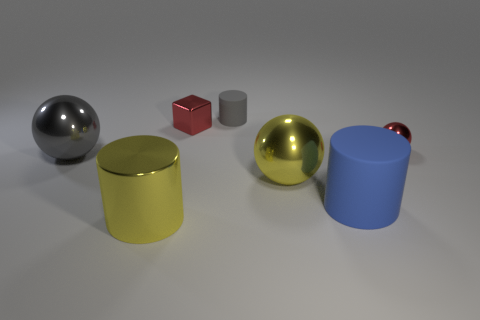Does the metal cylinder have the same color as the small cylinder?
Give a very brief answer. No. What material is the gray thing right of the yellow shiny cylinder?
Keep it short and to the point. Rubber. What number of tiny things are either blue balls or gray cylinders?
Give a very brief answer. 1. Is there a tiny ball that has the same material as the small gray object?
Make the answer very short. No. There is a gray rubber cylinder behind the red sphere; is it the same size as the tiny cube?
Your answer should be very brief. Yes. There is a small metal object that is right of the big yellow metallic object that is to the right of the large shiny cylinder; is there a sphere in front of it?
Keep it short and to the point. Yes. What number of matte things are gray things or yellow spheres?
Ensure brevity in your answer.  1. What number of other objects are there of the same shape as the gray metallic object?
Your response must be concise. 2. Are there more big gray objects than purple shiny cubes?
Offer a terse response. Yes. There is a red metallic object that is behind the red metallic object right of the metallic object behind the tiny metal sphere; what is its size?
Your answer should be compact. Small. 